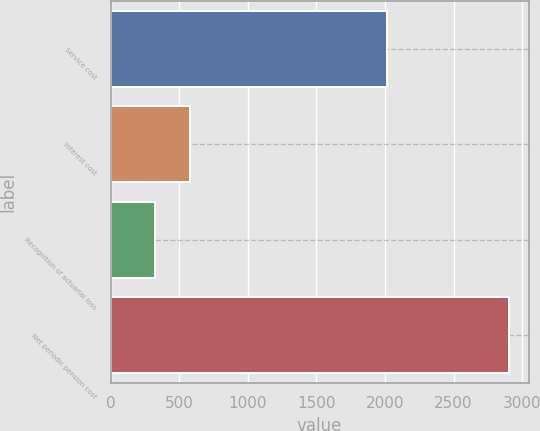<chart> <loc_0><loc_0><loc_500><loc_500><bar_chart><fcel>Service cost<fcel>Interest cost<fcel>Recognition of actuarial loss<fcel>Net periodic pension cost<nl><fcel>2013<fcel>579.2<fcel>321<fcel>2903<nl></chart> 